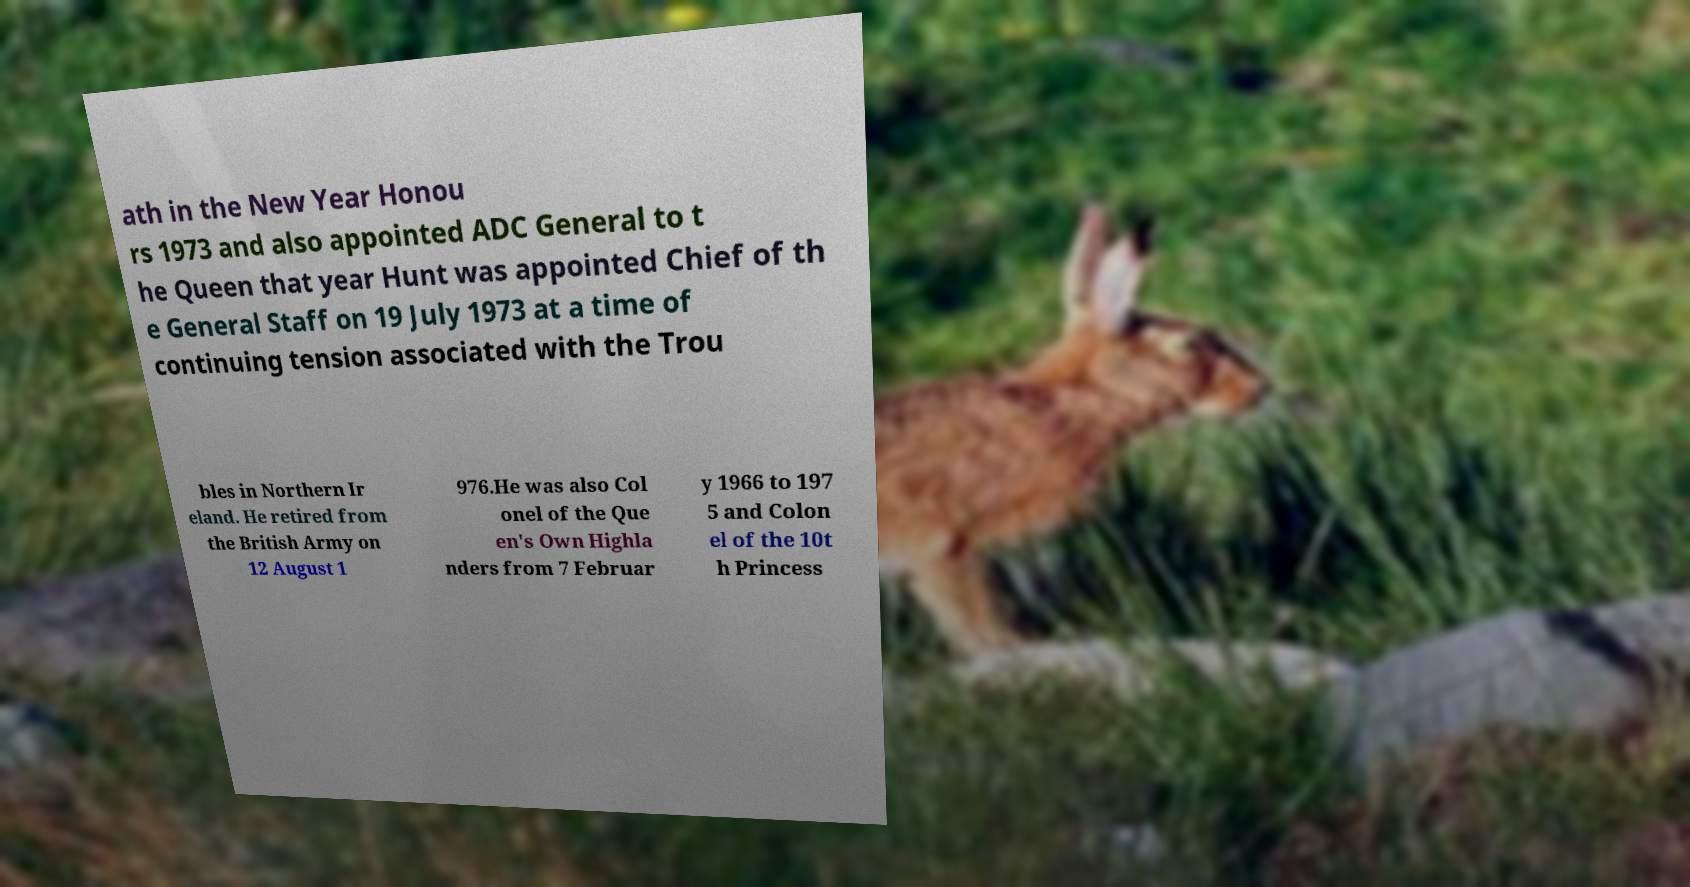Could you extract and type out the text from this image? ath in the New Year Honou rs 1973 and also appointed ADC General to t he Queen that year Hunt was appointed Chief of th e General Staff on 19 July 1973 at a time of continuing tension associated with the Trou bles in Northern Ir eland. He retired from the British Army on 12 August 1 976.He was also Col onel of the Que en's Own Highla nders from 7 Februar y 1966 to 197 5 and Colon el of the 10t h Princess 